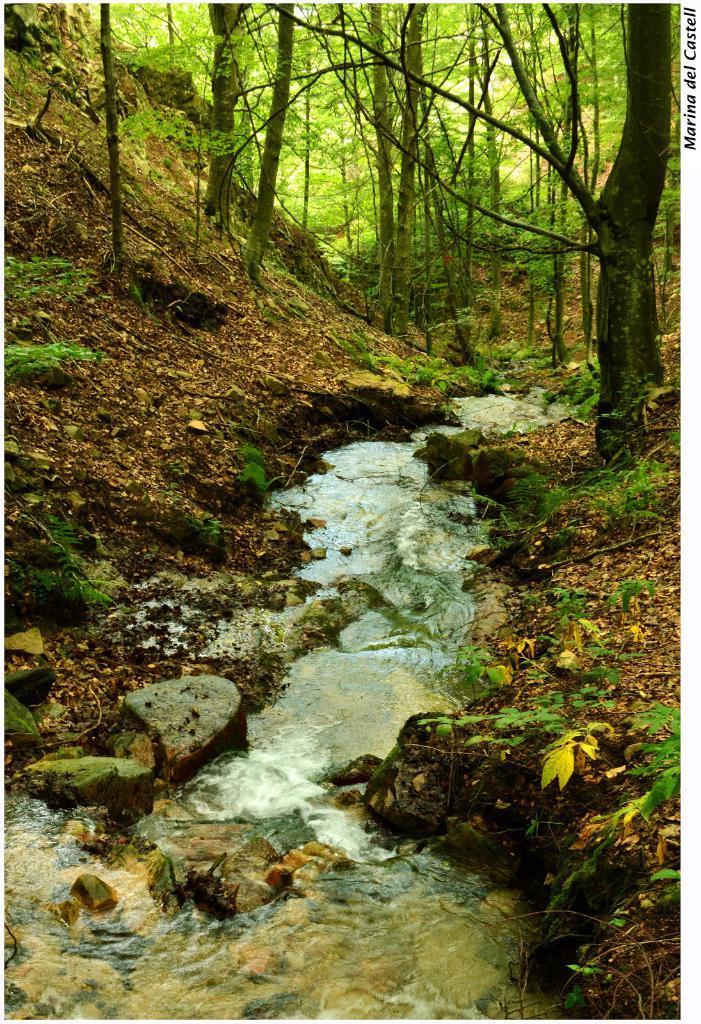Can you describe this image briefly? In the given image the forest area and the flowing river is shown. 